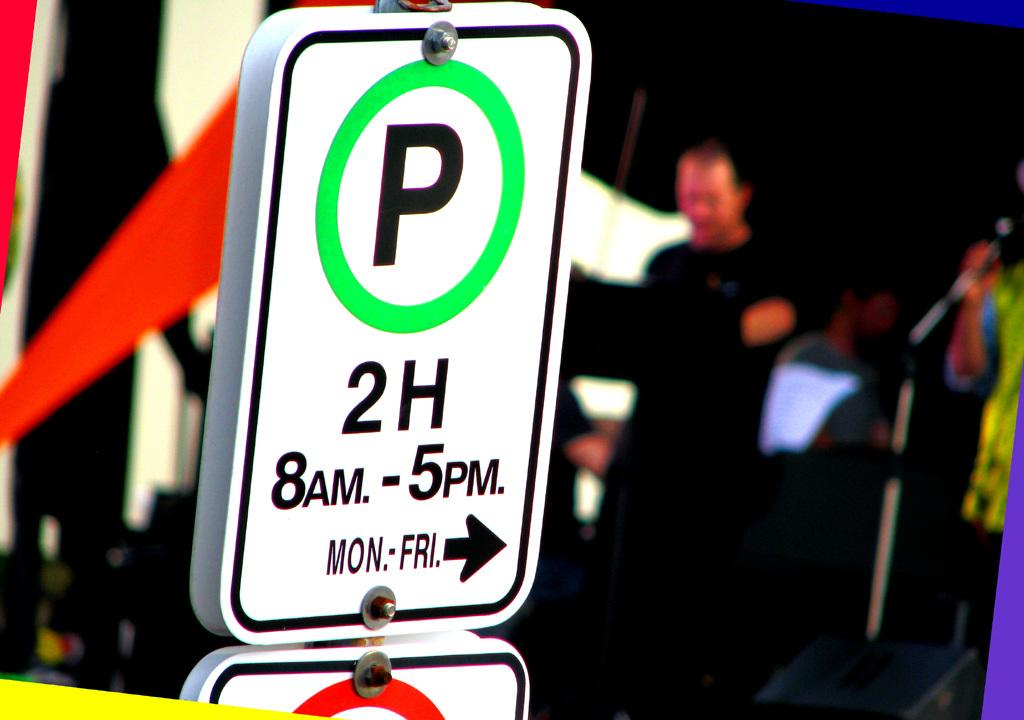What time can i park?
Provide a succinct answer. 8am - 5pm. Can i park here on the week-end?
Provide a succinct answer. No. 